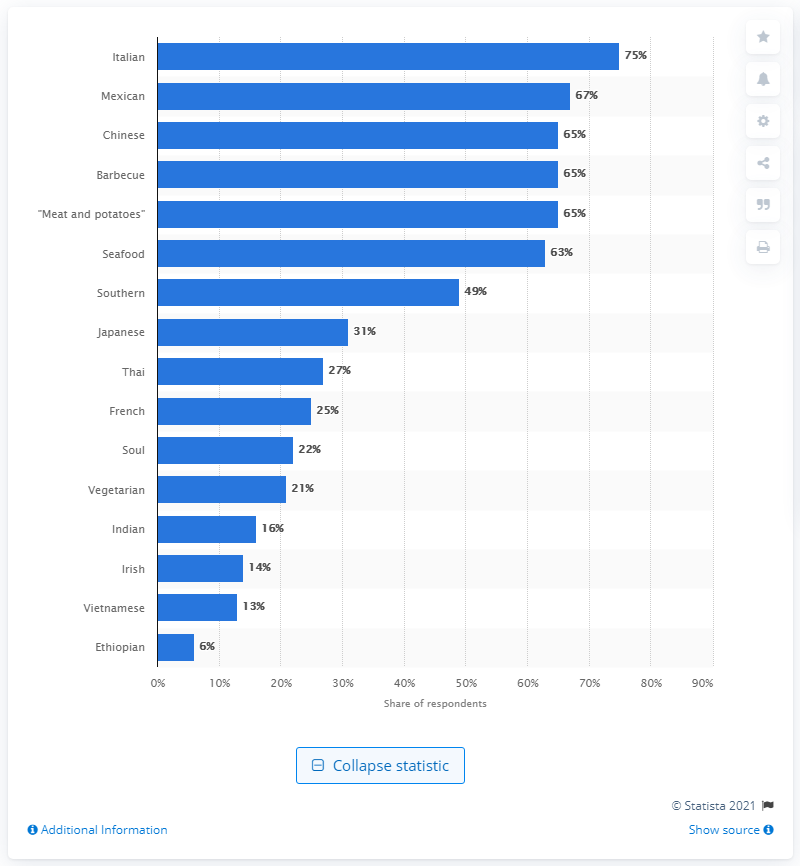Indicate a few pertinent items in this graphic. According to a survey, 75% of Americans claim that Italian cuisine is their favorite type of meal to eat. 